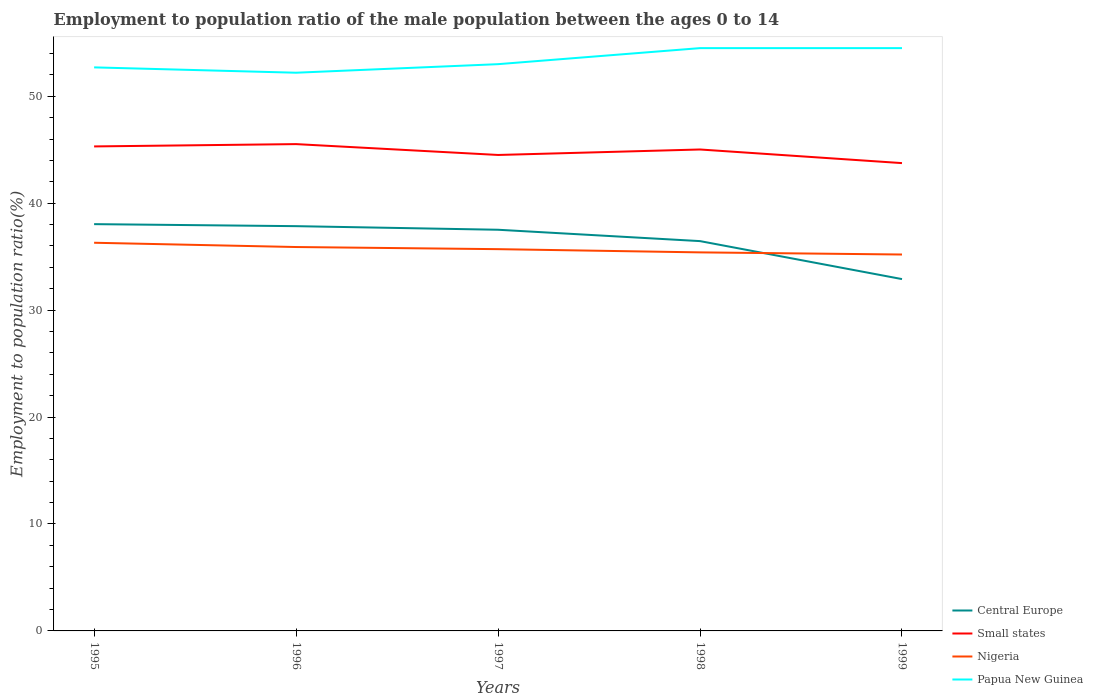Does the line corresponding to Central Europe intersect with the line corresponding to Small states?
Offer a terse response. No. Across all years, what is the maximum employment to population ratio in Small states?
Offer a very short reply. 43.75. What is the total employment to population ratio in Papua New Guinea in the graph?
Your response must be concise. 0. What is the difference between the highest and the second highest employment to population ratio in Papua New Guinea?
Your response must be concise. 2.3. How many lines are there?
Your answer should be very brief. 4. How many years are there in the graph?
Give a very brief answer. 5. Are the values on the major ticks of Y-axis written in scientific E-notation?
Ensure brevity in your answer.  No. Does the graph contain any zero values?
Provide a succinct answer. No. What is the title of the graph?
Ensure brevity in your answer.  Employment to population ratio of the male population between the ages 0 to 14. What is the label or title of the Y-axis?
Provide a succinct answer. Employment to population ratio(%). What is the Employment to population ratio(%) of Central Europe in 1995?
Ensure brevity in your answer.  38.04. What is the Employment to population ratio(%) in Small states in 1995?
Offer a very short reply. 45.31. What is the Employment to population ratio(%) in Nigeria in 1995?
Make the answer very short. 36.3. What is the Employment to population ratio(%) in Papua New Guinea in 1995?
Ensure brevity in your answer.  52.7. What is the Employment to population ratio(%) in Central Europe in 1996?
Your response must be concise. 37.85. What is the Employment to population ratio(%) in Small states in 1996?
Offer a very short reply. 45.52. What is the Employment to population ratio(%) of Nigeria in 1996?
Your answer should be compact. 35.9. What is the Employment to population ratio(%) in Papua New Guinea in 1996?
Your response must be concise. 52.2. What is the Employment to population ratio(%) of Central Europe in 1997?
Your response must be concise. 37.52. What is the Employment to population ratio(%) of Small states in 1997?
Make the answer very short. 44.51. What is the Employment to population ratio(%) of Nigeria in 1997?
Provide a succinct answer. 35.7. What is the Employment to population ratio(%) in Central Europe in 1998?
Your answer should be very brief. 36.45. What is the Employment to population ratio(%) in Small states in 1998?
Provide a short and direct response. 45.02. What is the Employment to population ratio(%) of Nigeria in 1998?
Ensure brevity in your answer.  35.4. What is the Employment to population ratio(%) of Papua New Guinea in 1998?
Your response must be concise. 54.5. What is the Employment to population ratio(%) of Central Europe in 1999?
Make the answer very short. 32.9. What is the Employment to population ratio(%) of Small states in 1999?
Your answer should be very brief. 43.75. What is the Employment to population ratio(%) of Nigeria in 1999?
Give a very brief answer. 35.2. What is the Employment to population ratio(%) of Papua New Guinea in 1999?
Give a very brief answer. 54.5. Across all years, what is the maximum Employment to population ratio(%) of Central Europe?
Make the answer very short. 38.04. Across all years, what is the maximum Employment to population ratio(%) in Small states?
Ensure brevity in your answer.  45.52. Across all years, what is the maximum Employment to population ratio(%) in Nigeria?
Make the answer very short. 36.3. Across all years, what is the maximum Employment to population ratio(%) of Papua New Guinea?
Your answer should be compact. 54.5. Across all years, what is the minimum Employment to population ratio(%) in Central Europe?
Ensure brevity in your answer.  32.9. Across all years, what is the minimum Employment to population ratio(%) of Small states?
Give a very brief answer. 43.75. Across all years, what is the minimum Employment to population ratio(%) of Nigeria?
Your answer should be very brief. 35.2. Across all years, what is the minimum Employment to population ratio(%) in Papua New Guinea?
Your answer should be very brief. 52.2. What is the total Employment to population ratio(%) of Central Europe in the graph?
Keep it short and to the point. 182.76. What is the total Employment to population ratio(%) of Small states in the graph?
Offer a terse response. 224.11. What is the total Employment to population ratio(%) in Nigeria in the graph?
Keep it short and to the point. 178.5. What is the total Employment to population ratio(%) in Papua New Guinea in the graph?
Keep it short and to the point. 266.9. What is the difference between the Employment to population ratio(%) in Central Europe in 1995 and that in 1996?
Provide a succinct answer. 0.19. What is the difference between the Employment to population ratio(%) in Small states in 1995 and that in 1996?
Ensure brevity in your answer.  -0.22. What is the difference between the Employment to population ratio(%) in Nigeria in 1995 and that in 1996?
Give a very brief answer. 0.4. What is the difference between the Employment to population ratio(%) of Papua New Guinea in 1995 and that in 1996?
Give a very brief answer. 0.5. What is the difference between the Employment to population ratio(%) of Central Europe in 1995 and that in 1997?
Your answer should be compact. 0.52. What is the difference between the Employment to population ratio(%) in Small states in 1995 and that in 1997?
Provide a short and direct response. 0.8. What is the difference between the Employment to population ratio(%) in Papua New Guinea in 1995 and that in 1997?
Offer a very short reply. -0.3. What is the difference between the Employment to population ratio(%) in Central Europe in 1995 and that in 1998?
Provide a succinct answer. 1.59. What is the difference between the Employment to population ratio(%) of Small states in 1995 and that in 1998?
Provide a short and direct response. 0.29. What is the difference between the Employment to population ratio(%) of Papua New Guinea in 1995 and that in 1998?
Your response must be concise. -1.8. What is the difference between the Employment to population ratio(%) in Central Europe in 1995 and that in 1999?
Provide a short and direct response. 5.14. What is the difference between the Employment to population ratio(%) in Small states in 1995 and that in 1999?
Offer a terse response. 1.56. What is the difference between the Employment to population ratio(%) in Nigeria in 1995 and that in 1999?
Your answer should be compact. 1.1. What is the difference between the Employment to population ratio(%) of Papua New Guinea in 1995 and that in 1999?
Keep it short and to the point. -1.8. What is the difference between the Employment to population ratio(%) in Central Europe in 1996 and that in 1997?
Offer a terse response. 0.34. What is the difference between the Employment to population ratio(%) in Small states in 1996 and that in 1997?
Give a very brief answer. 1.02. What is the difference between the Employment to population ratio(%) in Nigeria in 1996 and that in 1997?
Your response must be concise. 0.2. What is the difference between the Employment to population ratio(%) in Central Europe in 1996 and that in 1998?
Provide a succinct answer. 1.4. What is the difference between the Employment to population ratio(%) of Small states in 1996 and that in 1998?
Your answer should be compact. 0.5. What is the difference between the Employment to population ratio(%) of Papua New Guinea in 1996 and that in 1998?
Make the answer very short. -2.3. What is the difference between the Employment to population ratio(%) of Central Europe in 1996 and that in 1999?
Give a very brief answer. 4.95. What is the difference between the Employment to population ratio(%) of Small states in 1996 and that in 1999?
Give a very brief answer. 1.78. What is the difference between the Employment to population ratio(%) of Nigeria in 1996 and that in 1999?
Your answer should be very brief. 0.7. What is the difference between the Employment to population ratio(%) of Papua New Guinea in 1996 and that in 1999?
Provide a succinct answer. -2.3. What is the difference between the Employment to population ratio(%) in Central Europe in 1997 and that in 1998?
Your answer should be compact. 1.06. What is the difference between the Employment to population ratio(%) of Small states in 1997 and that in 1998?
Your answer should be very brief. -0.51. What is the difference between the Employment to population ratio(%) of Nigeria in 1997 and that in 1998?
Your answer should be very brief. 0.3. What is the difference between the Employment to population ratio(%) of Central Europe in 1997 and that in 1999?
Your response must be concise. 4.61. What is the difference between the Employment to population ratio(%) in Small states in 1997 and that in 1999?
Ensure brevity in your answer.  0.76. What is the difference between the Employment to population ratio(%) of Nigeria in 1997 and that in 1999?
Offer a terse response. 0.5. What is the difference between the Employment to population ratio(%) of Central Europe in 1998 and that in 1999?
Make the answer very short. 3.55. What is the difference between the Employment to population ratio(%) of Small states in 1998 and that in 1999?
Offer a very short reply. 1.27. What is the difference between the Employment to population ratio(%) in Central Europe in 1995 and the Employment to population ratio(%) in Small states in 1996?
Provide a succinct answer. -7.49. What is the difference between the Employment to population ratio(%) in Central Europe in 1995 and the Employment to population ratio(%) in Nigeria in 1996?
Give a very brief answer. 2.14. What is the difference between the Employment to population ratio(%) of Central Europe in 1995 and the Employment to population ratio(%) of Papua New Guinea in 1996?
Your answer should be compact. -14.16. What is the difference between the Employment to population ratio(%) in Small states in 1995 and the Employment to population ratio(%) in Nigeria in 1996?
Your answer should be very brief. 9.41. What is the difference between the Employment to population ratio(%) in Small states in 1995 and the Employment to population ratio(%) in Papua New Guinea in 1996?
Provide a succinct answer. -6.89. What is the difference between the Employment to population ratio(%) of Nigeria in 1995 and the Employment to population ratio(%) of Papua New Guinea in 1996?
Your answer should be very brief. -15.9. What is the difference between the Employment to population ratio(%) in Central Europe in 1995 and the Employment to population ratio(%) in Small states in 1997?
Provide a short and direct response. -6.47. What is the difference between the Employment to population ratio(%) of Central Europe in 1995 and the Employment to population ratio(%) of Nigeria in 1997?
Provide a succinct answer. 2.34. What is the difference between the Employment to population ratio(%) in Central Europe in 1995 and the Employment to population ratio(%) in Papua New Guinea in 1997?
Ensure brevity in your answer.  -14.96. What is the difference between the Employment to population ratio(%) in Small states in 1995 and the Employment to population ratio(%) in Nigeria in 1997?
Offer a very short reply. 9.61. What is the difference between the Employment to population ratio(%) in Small states in 1995 and the Employment to population ratio(%) in Papua New Guinea in 1997?
Your answer should be compact. -7.69. What is the difference between the Employment to population ratio(%) in Nigeria in 1995 and the Employment to population ratio(%) in Papua New Guinea in 1997?
Provide a succinct answer. -16.7. What is the difference between the Employment to population ratio(%) of Central Europe in 1995 and the Employment to population ratio(%) of Small states in 1998?
Your answer should be compact. -6.98. What is the difference between the Employment to population ratio(%) in Central Europe in 1995 and the Employment to population ratio(%) in Nigeria in 1998?
Give a very brief answer. 2.64. What is the difference between the Employment to population ratio(%) in Central Europe in 1995 and the Employment to population ratio(%) in Papua New Guinea in 1998?
Offer a very short reply. -16.46. What is the difference between the Employment to population ratio(%) of Small states in 1995 and the Employment to population ratio(%) of Nigeria in 1998?
Provide a succinct answer. 9.91. What is the difference between the Employment to population ratio(%) of Small states in 1995 and the Employment to population ratio(%) of Papua New Guinea in 1998?
Offer a very short reply. -9.19. What is the difference between the Employment to population ratio(%) of Nigeria in 1995 and the Employment to population ratio(%) of Papua New Guinea in 1998?
Your answer should be very brief. -18.2. What is the difference between the Employment to population ratio(%) of Central Europe in 1995 and the Employment to population ratio(%) of Small states in 1999?
Your answer should be very brief. -5.71. What is the difference between the Employment to population ratio(%) of Central Europe in 1995 and the Employment to population ratio(%) of Nigeria in 1999?
Give a very brief answer. 2.84. What is the difference between the Employment to population ratio(%) of Central Europe in 1995 and the Employment to population ratio(%) of Papua New Guinea in 1999?
Provide a succinct answer. -16.46. What is the difference between the Employment to population ratio(%) of Small states in 1995 and the Employment to population ratio(%) of Nigeria in 1999?
Provide a short and direct response. 10.11. What is the difference between the Employment to population ratio(%) of Small states in 1995 and the Employment to population ratio(%) of Papua New Guinea in 1999?
Offer a terse response. -9.19. What is the difference between the Employment to population ratio(%) of Nigeria in 1995 and the Employment to population ratio(%) of Papua New Guinea in 1999?
Your response must be concise. -18.2. What is the difference between the Employment to population ratio(%) in Central Europe in 1996 and the Employment to population ratio(%) in Small states in 1997?
Provide a succinct answer. -6.66. What is the difference between the Employment to population ratio(%) of Central Europe in 1996 and the Employment to population ratio(%) of Nigeria in 1997?
Keep it short and to the point. 2.15. What is the difference between the Employment to population ratio(%) in Central Europe in 1996 and the Employment to population ratio(%) in Papua New Guinea in 1997?
Provide a short and direct response. -15.15. What is the difference between the Employment to population ratio(%) of Small states in 1996 and the Employment to population ratio(%) of Nigeria in 1997?
Your response must be concise. 9.82. What is the difference between the Employment to population ratio(%) of Small states in 1996 and the Employment to population ratio(%) of Papua New Guinea in 1997?
Your response must be concise. -7.48. What is the difference between the Employment to population ratio(%) of Nigeria in 1996 and the Employment to population ratio(%) of Papua New Guinea in 1997?
Your answer should be compact. -17.1. What is the difference between the Employment to population ratio(%) in Central Europe in 1996 and the Employment to population ratio(%) in Small states in 1998?
Offer a terse response. -7.17. What is the difference between the Employment to population ratio(%) of Central Europe in 1996 and the Employment to population ratio(%) of Nigeria in 1998?
Your answer should be compact. 2.45. What is the difference between the Employment to population ratio(%) of Central Europe in 1996 and the Employment to population ratio(%) of Papua New Guinea in 1998?
Make the answer very short. -16.65. What is the difference between the Employment to population ratio(%) in Small states in 1996 and the Employment to population ratio(%) in Nigeria in 1998?
Offer a terse response. 10.12. What is the difference between the Employment to population ratio(%) of Small states in 1996 and the Employment to population ratio(%) of Papua New Guinea in 1998?
Offer a terse response. -8.98. What is the difference between the Employment to population ratio(%) of Nigeria in 1996 and the Employment to population ratio(%) of Papua New Guinea in 1998?
Your answer should be compact. -18.6. What is the difference between the Employment to population ratio(%) in Central Europe in 1996 and the Employment to population ratio(%) in Small states in 1999?
Offer a very short reply. -5.89. What is the difference between the Employment to population ratio(%) of Central Europe in 1996 and the Employment to population ratio(%) of Nigeria in 1999?
Your answer should be compact. 2.65. What is the difference between the Employment to population ratio(%) of Central Europe in 1996 and the Employment to population ratio(%) of Papua New Guinea in 1999?
Keep it short and to the point. -16.65. What is the difference between the Employment to population ratio(%) in Small states in 1996 and the Employment to population ratio(%) in Nigeria in 1999?
Provide a short and direct response. 10.32. What is the difference between the Employment to population ratio(%) of Small states in 1996 and the Employment to population ratio(%) of Papua New Guinea in 1999?
Ensure brevity in your answer.  -8.98. What is the difference between the Employment to population ratio(%) of Nigeria in 1996 and the Employment to population ratio(%) of Papua New Guinea in 1999?
Your response must be concise. -18.6. What is the difference between the Employment to population ratio(%) of Central Europe in 1997 and the Employment to population ratio(%) of Small states in 1998?
Your response must be concise. -7.51. What is the difference between the Employment to population ratio(%) of Central Europe in 1997 and the Employment to population ratio(%) of Nigeria in 1998?
Keep it short and to the point. 2.12. What is the difference between the Employment to population ratio(%) of Central Europe in 1997 and the Employment to population ratio(%) of Papua New Guinea in 1998?
Give a very brief answer. -16.98. What is the difference between the Employment to population ratio(%) in Small states in 1997 and the Employment to population ratio(%) in Nigeria in 1998?
Ensure brevity in your answer.  9.11. What is the difference between the Employment to population ratio(%) of Small states in 1997 and the Employment to population ratio(%) of Papua New Guinea in 1998?
Offer a terse response. -9.99. What is the difference between the Employment to population ratio(%) of Nigeria in 1997 and the Employment to population ratio(%) of Papua New Guinea in 1998?
Ensure brevity in your answer.  -18.8. What is the difference between the Employment to population ratio(%) in Central Europe in 1997 and the Employment to population ratio(%) in Small states in 1999?
Your answer should be very brief. -6.23. What is the difference between the Employment to population ratio(%) of Central Europe in 1997 and the Employment to population ratio(%) of Nigeria in 1999?
Your answer should be compact. 2.32. What is the difference between the Employment to population ratio(%) in Central Europe in 1997 and the Employment to population ratio(%) in Papua New Guinea in 1999?
Your answer should be very brief. -16.98. What is the difference between the Employment to population ratio(%) in Small states in 1997 and the Employment to population ratio(%) in Nigeria in 1999?
Offer a terse response. 9.31. What is the difference between the Employment to population ratio(%) in Small states in 1997 and the Employment to population ratio(%) in Papua New Guinea in 1999?
Give a very brief answer. -9.99. What is the difference between the Employment to population ratio(%) in Nigeria in 1997 and the Employment to population ratio(%) in Papua New Guinea in 1999?
Your response must be concise. -18.8. What is the difference between the Employment to population ratio(%) in Central Europe in 1998 and the Employment to population ratio(%) in Small states in 1999?
Make the answer very short. -7.29. What is the difference between the Employment to population ratio(%) of Central Europe in 1998 and the Employment to population ratio(%) of Nigeria in 1999?
Provide a short and direct response. 1.25. What is the difference between the Employment to population ratio(%) in Central Europe in 1998 and the Employment to population ratio(%) in Papua New Guinea in 1999?
Keep it short and to the point. -18.05. What is the difference between the Employment to population ratio(%) of Small states in 1998 and the Employment to population ratio(%) of Nigeria in 1999?
Your answer should be compact. 9.82. What is the difference between the Employment to population ratio(%) in Small states in 1998 and the Employment to population ratio(%) in Papua New Guinea in 1999?
Keep it short and to the point. -9.48. What is the difference between the Employment to population ratio(%) in Nigeria in 1998 and the Employment to population ratio(%) in Papua New Guinea in 1999?
Your response must be concise. -19.1. What is the average Employment to population ratio(%) of Central Europe per year?
Your answer should be very brief. 36.55. What is the average Employment to population ratio(%) in Small states per year?
Your response must be concise. 44.82. What is the average Employment to population ratio(%) in Nigeria per year?
Make the answer very short. 35.7. What is the average Employment to population ratio(%) in Papua New Guinea per year?
Your answer should be compact. 53.38. In the year 1995, what is the difference between the Employment to population ratio(%) in Central Europe and Employment to population ratio(%) in Small states?
Offer a terse response. -7.27. In the year 1995, what is the difference between the Employment to population ratio(%) of Central Europe and Employment to population ratio(%) of Nigeria?
Ensure brevity in your answer.  1.74. In the year 1995, what is the difference between the Employment to population ratio(%) in Central Europe and Employment to population ratio(%) in Papua New Guinea?
Keep it short and to the point. -14.66. In the year 1995, what is the difference between the Employment to population ratio(%) in Small states and Employment to population ratio(%) in Nigeria?
Your answer should be compact. 9.01. In the year 1995, what is the difference between the Employment to population ratio(%) of Small states and Employment to population ratio(%) of Papua New Guinea?
Make the answer very short. -7.39. In the year 1995, what is the difference between the Employment to population ratio(%) in Nigeria and Employment to population ratio(%) in Papua New Guinea?
Your response must be concise. -16.4. In the year 1996, what is the difference between the Employment to population ratio(%) in Central Europe and Employment to population ratio(%) in Small states?
Make the answer very short. -7.67. In the year 1996, what is the difference between the Employment to population ratio(%) of Central Europe and Employment to population ratio(%) of Nigeria?
Keep it short and to the point. 1.95. In the year 1996, what is the difference between the Employment to population ratio(%) in Central Europe and Employment to population ratio(%) in Papua New Guinea?
Keep it short and to the point. -14.35. In the year 1996, what is the difference between the Employment to population ratio(%) in Small states and Employment to population ratio(%) in Nigeria?
Provide a short and direct response. 9.62. In the year 1996, what is the difference between the Employment to population ratio(%) in Small states and Employment to population ratio(%) in Papua New Guinea?
Make the answer very short. -6.68. In the year 1996, what is the difference between the Employment to population ratio(%) of Nigeria and Employment to population ratio(%) of Papua New Guinea?
Give a very brief answer. -16.3. In the year 1997, what is the difference between the Employment to population ratio(%) in Central Europe and Employment to population ratio(%) in Small states?
Your answer should be very brief. -6.99. In the year 1997, what is the difference between the Employment to population ratio(%) in Central Europe and Employment to population ratio(%) in Nigeria?
Make the answer very short. 1.82. In the year 1997, what is the difference between the Employment to population ratio(%) of Central Europe and Employment to population ratio(%) of Papua New Guinea?
Your response must be concise. -15.48. In the year 1997, what is the difference between the Employment to population ratio(%) of Small states and Employment to population ratio(%) of Nigeria?
Provide a short and direct response. 8.81. In the year 1997, what is the difference between the Employment to population ratio(%) in Small states and Employment to population ratio(%) in Papua New Guinea?
Provide a succinct answer. -8.49. In the year 1997, what is the difference between the Employment to population ratio(%) in Nigeria and Employment to population ratio(%) in Papua New Guinea?
Provide a succinct answer. -17.3. In the year 1998, what is the difference between the Employment to population ratio(%) of Central Europe and Employment to population ratio(%) of Small states?
Ensure brevity in your answer.  -8.57. In the year 1998, what is the difference between the Employment to population ratio(%) in Central Europe and Employment to population ratio(%) in Nigeria?
Your answer should be very brief. 1.05. In the year 1998, what is the difference between the Employment to population ratio(%) in Central Europe and Employment to population ratio(%) in Papua New Guinea?
Your answer should be compact. -18.05. In the year 1998, what is the difference between the Employment to population ratio(%) of Small states and Employment to population ratio(%) of Nigeria?
Ensure brevity in your answer.  9.62. In the year 1998, what is the difference between the Employment to population ratio(%) of Small states and Employment to population ratio(%) of Papua New Guinea?
Make the answer very short. -9.48. In the year 1998, what is the difference between the Employment to population ratio(%) in Nigeria and Employment to population ratio(%) in Papua New Guinea?
Your response must be concise. -19.1. In the year 1999, what is the difference between the Employment to population ratio(%) in Central Europe and Employment to population ratio(%) in Small states?
Make the answer very short. -10.85. In the year 1999, what is the difference between the Employment to population ratio(%) in Central Europe and Employment to population ratio(%) in Nigeria?
Your response must be concise. -2.3. In the year 1999, what is the difference between the Employment to population ratio(%) in Central Europe and Employment to population ratio(%) in Papua New Guinea?
Provide a short and direct response. -21.6. In the year 1999, what is the difference between the Employment to population ratio(%) of Small states and Employment to population ratio(%) of Nigeria?
Provide a short and direct response. 8.55. In the year 1999, what is the difference between the Employment to population ratio(%) of Small states and Employment to population ratio(%) of Papua New Guinea?
Offer a very short reply. -10.75. In the year 1999, what is the difference between the Employment to population ratio(%) of Nigeria and Employment to population ratio(%) of Papua New Guinea?
Your answer should be very brief. -19.3. What is the ratio of the Employment to population ratio(%) of Central Europe in 1995 to that in 1996?
Provide a short and direct response. 1. What is the ratio of the Employment to population ratio(%) of Nigeria in 1995 to that in 1996?
Make the answer very short. 1.01. What is the ratio of the Employment to population ratio(%) of Papua New Guinea in 1995 to that in 1996?
Provide a short and direct response. 1.01. What is the ratio of the Employment to population ratio(%) in Central Europe in 1995 to that in 1997?
Make the answer very short. 1.01. What is the ratio of the Employment to population ratio(%) in Small states in 1995 to that in 1997?
Keep it short and to the point. 1.02. What is the ratio of the Employment to population ratio(%) in Nigeria in 1995 to that in 1997?
Offer a terse response. 1.02. What is the ratio of the Employment to population ratio(%) in Papua New Guinea in 1995 to that in 1997?
Your response must be concise. 0.99. What is the ratio of the Employment to population ratio(%) in Central Europe in 1995 to that in 1998?
Offer a very short reply. 1.04. What is the ratio of the Employment to population ratio(%) of Nigeria in 1995 to that in 1998?
Your response must be concise. 1.03. What is the ratio of the Employment to population ratio(%) in Central Europe in 1995 to that in 1999?
Offer a terse response. 1.16. What is the ratio of the Employment to population ratio(%) in Small states in 1995 to that in 1999?
Ensure brevity in your answer.  1.04. What is the ratio of the Employment to population ratio(%) of Nigeria in 1995 to that in 1999?
Give a very brief answer. 1.03. What is the ratio of the Employment to population ratio(%) of Central Europe in 1996 to that in 1997?
Keep it short and to the point. 1.01. What is the ratio of the Employment to population ratio(%) of Small states in 1996 to that in 1997?
Offer a very short reply. 1.02. What is the ratio of the Employment to population ratio(%) of Nigeria in 1996 to that in 1997?
Your answer should be very brief. 1.01. What is the ratio of the Employment to population ratio(%) of Papua New Guinea in 1996 to that in 1997?
Offer a terse response. 0.98. What is the ratio of the Employment to population ratio(%) in Central Europe in 1996 to that in 1998?
Keep it short and to the point. 1.04. What is the ratio of the Employment to population ratio(%) in Small states in 1996 to that in 1998?
Your answer should be very brief. 1.01. What is the ratio of the Employment to population ratio(%) of Nigeria in 1996 to that in 1998?
Your answer should be compact. 1.01. What is the ratio of the Employment to population ratio(%) of Papua New Guinea in 1996 to that in 1998?
Provide a short and direct response. 0.96. What is the ratio of the Employment to population ratio(%) of Central Europe in 1996 to that in 1999?
Provide a short and direct response. 1.15. What is the ratio of the Employment to population ratio(%) of Small states in 1996 to that in 1999?
Provide a short and direct response. 1.04. What is the ratio of the Employment to population ratio(%) in Nigeria in 1996 to that in 1999?
Keep it short and to the point. 1.02. What is the ratio of the Employment to population ratio(%) in Papua New Guinea in 1996 to that in 1999?
Offer a very short reply. 0.96. What is the ratio of the Employment to population ratio(%) in Central Europe in 1997 to that in 1998?
Provide a succinct answer. 1.03. What is the ratio of the Employment to population ratio(%) of Small states in 1997 to that in 1998?
Offer a terse response. 0.99. What is the ratio of the Employment to population ratio(%) in Nigeria in 1997 to that in 1998?
Your response must be concise. 1.01. What is the ratio of the Employment to population ratio(%) of Papua New Guinea in 1997 to that in 1998?
Your answer should be compact. 0.97. What is the ratio of the Employment to population ratio(%) in Central Europe in 1997 to that in 1999?
Your answer should be very brief. 1.14. What is the ratio of the Employment to population ratio(%) of Small states in 1997 to that in 1999?
Provide a short and direct response. 1.02. What is the ratio of the Employment to population ratio(%) of Nigeria in 1997 to that in 1999?
Your answer should be very brief. 1.01. What is the ratio of the Employment to population ratio(%) in Papua New Guinea in 1997 to that in 1999?
Provide a succinct answer. 0.97. What is the ratio of the Employment to population ratio(%) in Central Europe in 1998 to that in 1999?
Ensure brevity in your answer.  1.11. What is the ratio of the Employment to population ratio(%) in Small states in 1998 to that in 1999?
Offer a terse response. 1.03. What is the ratio of the Employment to population ratio(%) of Nigeria in 1998 to that in 1999?
Ensure brevity in your answer.  1.01. What is the ratio of the Employment to population ratio(%) in Papua New Guinea in 1998 to that in 1999?
Ensure brevity in your answer.  1. What is the difference between the highest and the second highest Employment to population ratio(%) of Central Europe?
Provide a succinct answer. 0.19. What is the difference between the highest and the second highest Employment to population ratio(%) of Small states?
Provide a succinct answer. 0.22. What is the difference between the highest and the lowest Employment to population ratio(%) of Central Europe?
Your response must be concise. 5.14. What is the difference between the highest and the lowest Employment to population ratio(%) of Small states?
Your answer should be very brief. 1.78. 